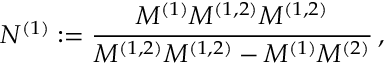<formula> <loc_0><loc_0><loc_500><loc_500>N ^ { ( 1 ) } \colon = \frac { M ^ { ( 1 ) } M ^ { ( 1 , 2 ) } M ^ { ( 1 , 2 ) } } { M ^ { ( 1 , 2 ) } M ^ { ( 1 , 2 ) } - M ^ { ( 1 ) } M ^ { ( 2 ) } } \, ,</formula> 